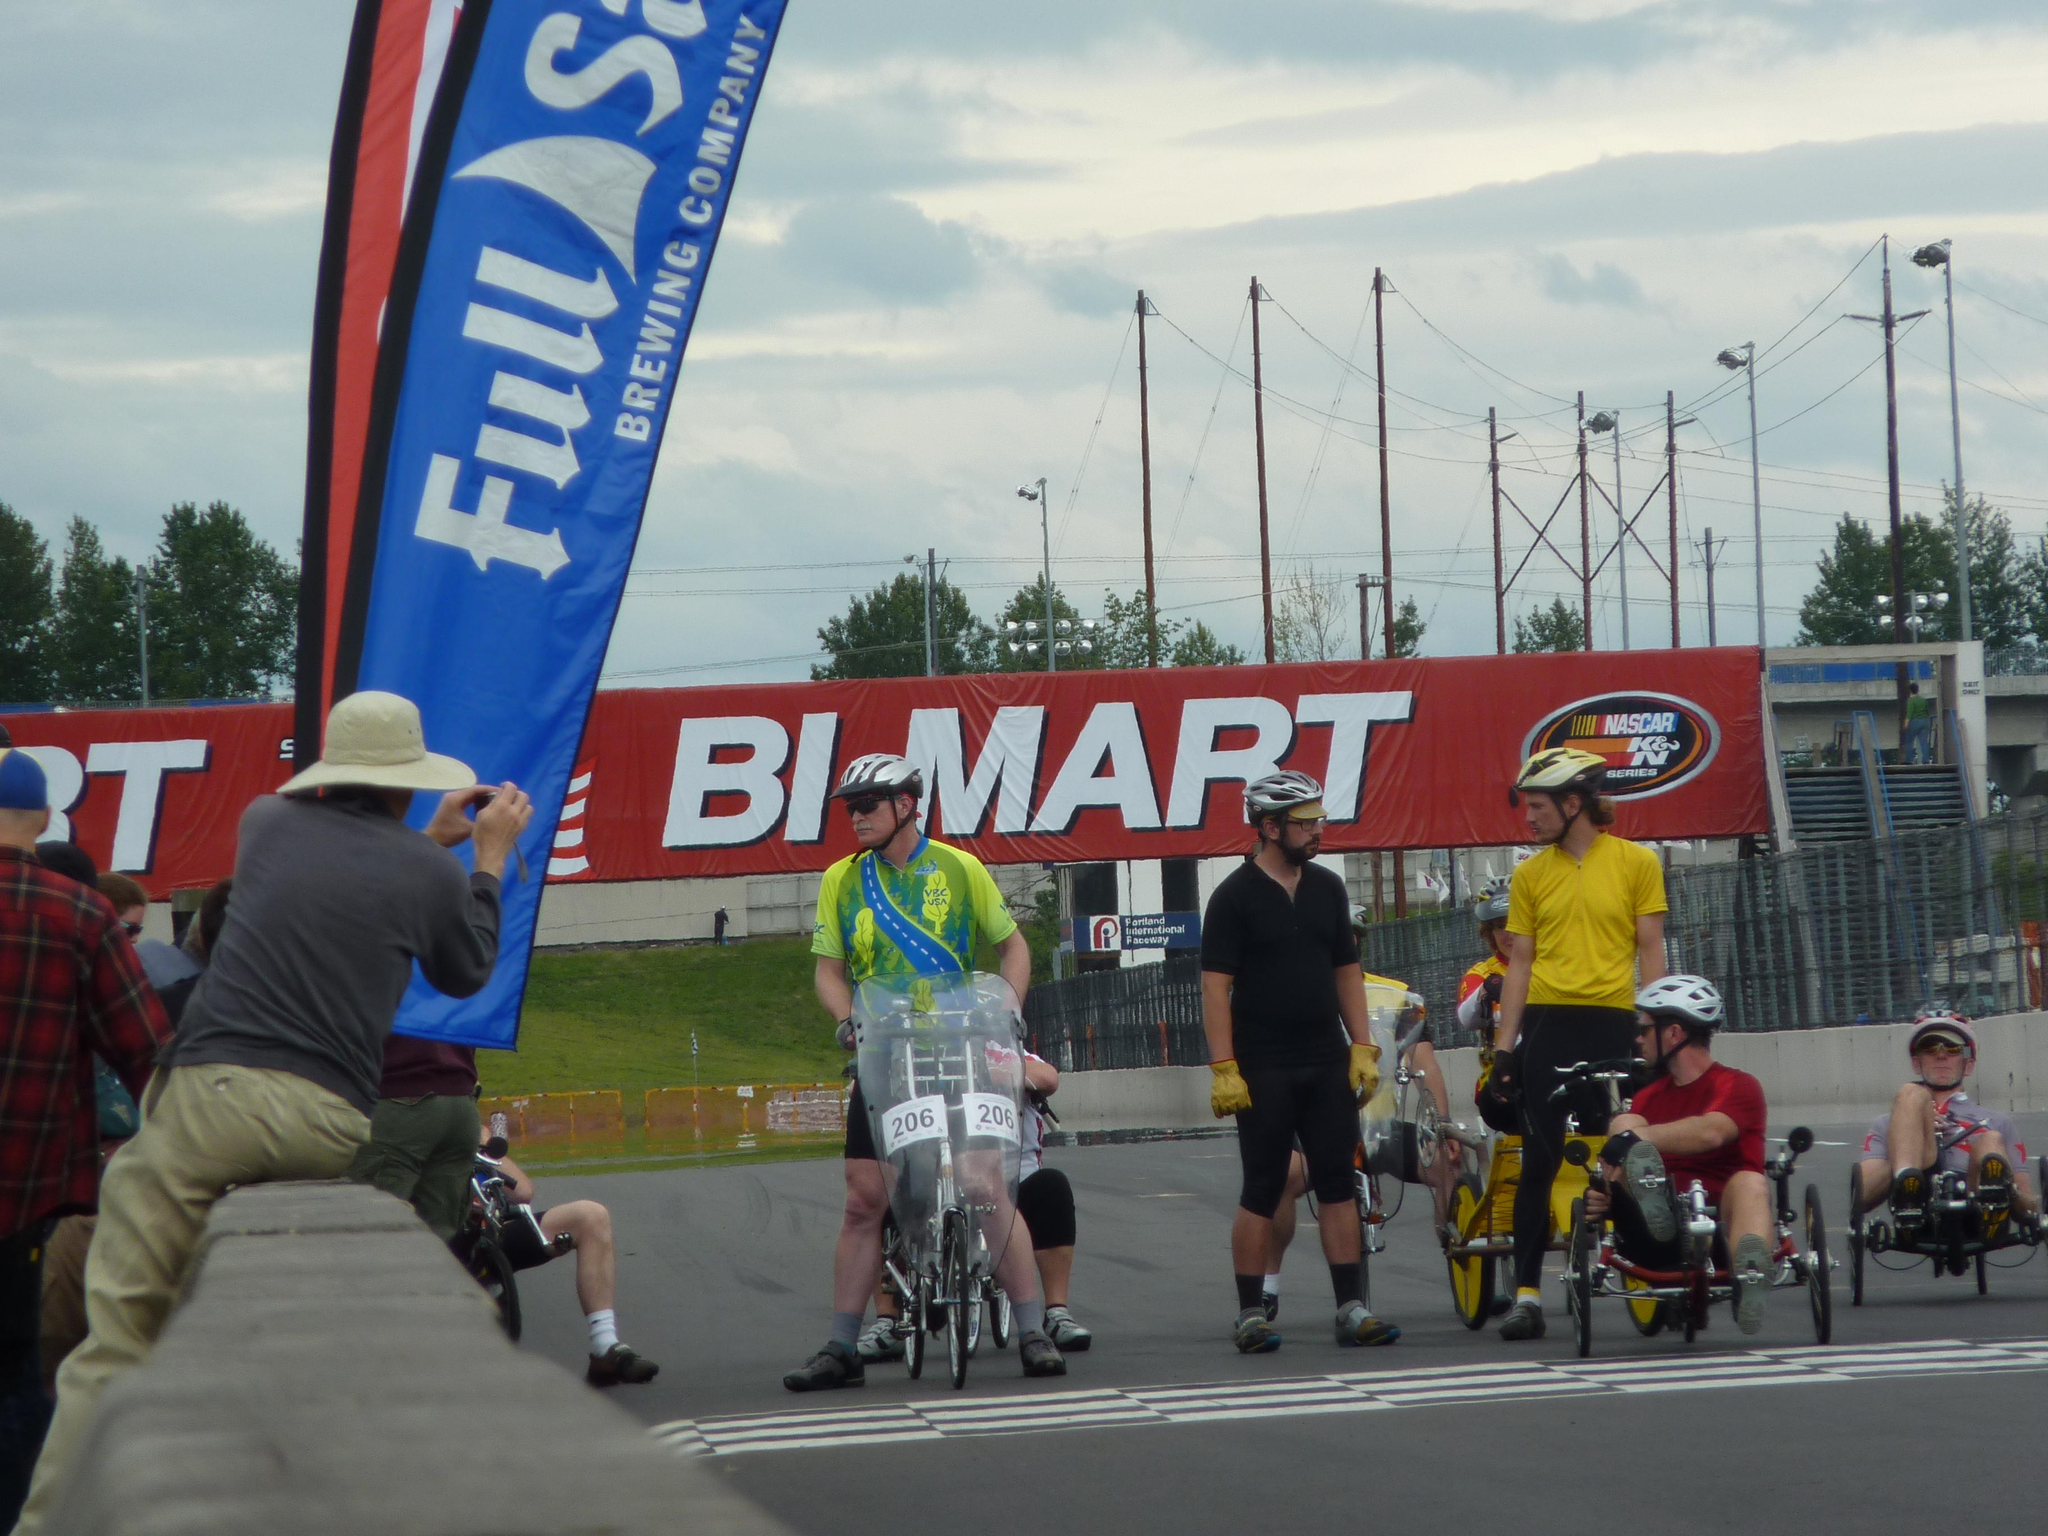What are the people doing in the image? There are people riding on a bicycle on the road, and people are sitting on a wall on the left side of the image. What can be seen behind the cyclists? There are hoardings visible behind the cyclists. What objects are present in the image that are not related to the people? There are poles visible in the image. What is visible in the background of the image? The sky is visible in the image. What are the people on the wall doing? The people on the wall are taking photos. How much dust can be seen on the visitor's shoes in the image? There is no visitor present in the image, and therefore no shoes or dust can be observed. 